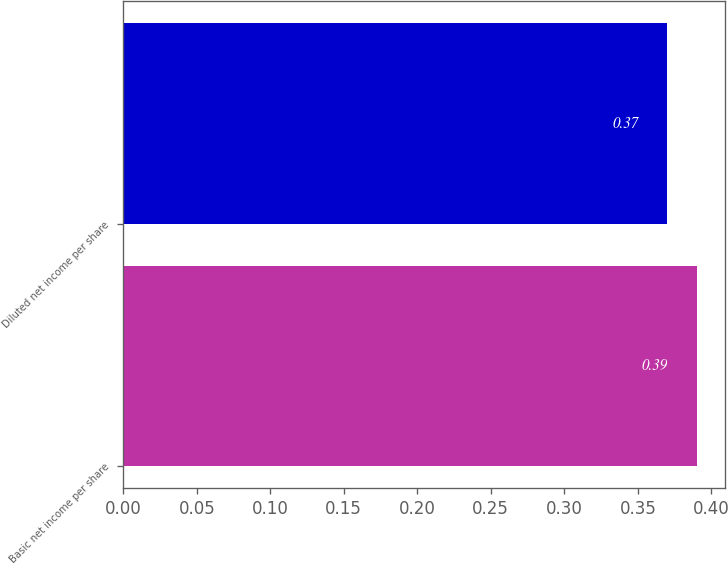<chart> <loc_0><loc_0><loc_500><loc_500><bar_chart><fcel>Basic net income per share<fcel>Diluted net income per share<nl><fcel>0.39<fcel>0.37<nl></chart> 